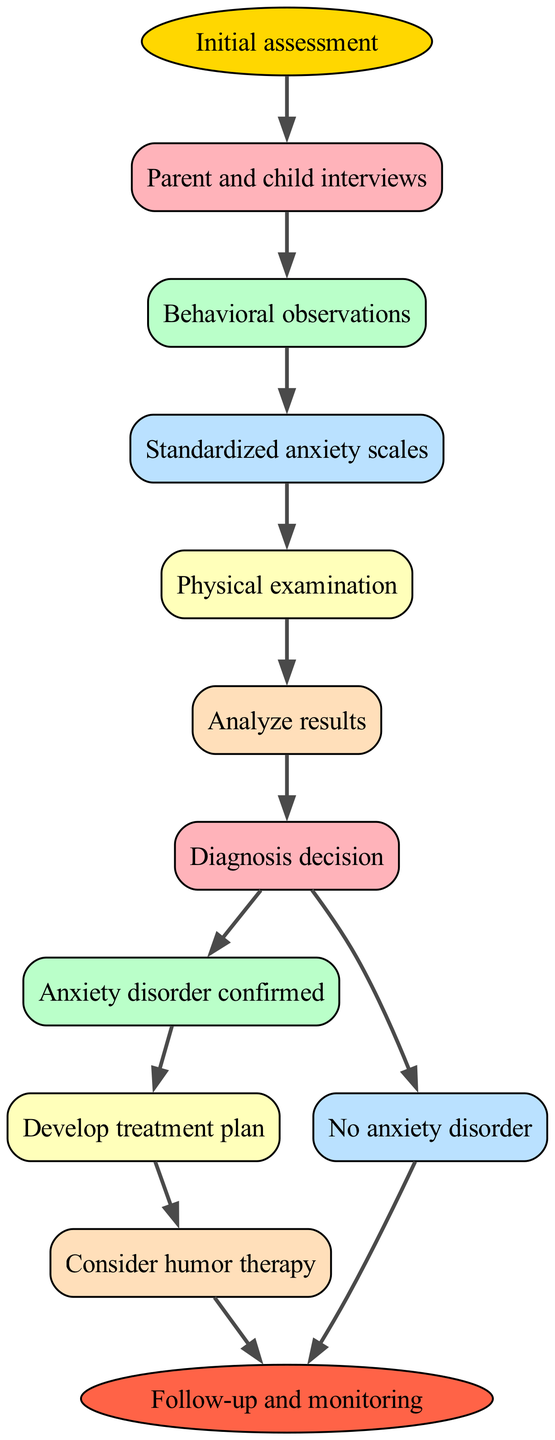What is the first step in the diagnostic procedure? The diagram indicates that the first step is labeled as "Initial assessment." This is shown directly connecting from the start node.
Answer: Initial assessment How many steps are there in total? By counting the steps listed in the diagram, there are six numbered steps plus the start and end nodes, which totals to eight nodes.
Answer: 8 What follows after the "Standardized anxiety scales"? According to the diagram, after "Standardized anxiety scales," the next step is "Physical examination," as indicated by the directed edge leading to that section.
Answer: Physical examination What are the two possible outcomes after the "Diagnosis decision"? The diagram shows two directed edges leading from "Diagnosis decision," leading to either "Anxiety disorder confirmed" or "No anxiety disorder." Therefore, the outcomes can be summarized as those two options.
Answer: Anxiety disorder confirmed, No anxiety disorder In which step is humor therapy considered in the flow? The diagram indicates that humor therapy is considered after the step labeled "Develop treatment plan," as it is the subsequent step that follows it.
Answer: Consider humor therapy If the diagnosis is confirmed, what is the next action? Following the "Anxiety disorder confirmed," the next step according to the flow is to "Develop treatment plan," which is the immediate action indicated in the diagram.
Answer: Develop treatment plan What is the final outcome of the flow chart? The flowchart concludes with the end node labeled "Follow-up and monitoring," showing the final goal of the diagnostic procedure.
Answer: Follow-up and monitoring Which step involves gathering information from parents? The step titled "Parent and child interviews" explicitly indicates that this action involves obtaining information from the parents as part of the assessment process.
Answer: Parent and child interviews What connects the "No anxiety disorder" step to the end? The step "No anxiety disorder" has a directed edge that connects it to the end node, which indicates that this outcome leads directly to concluding the procedure.
Answer: end 